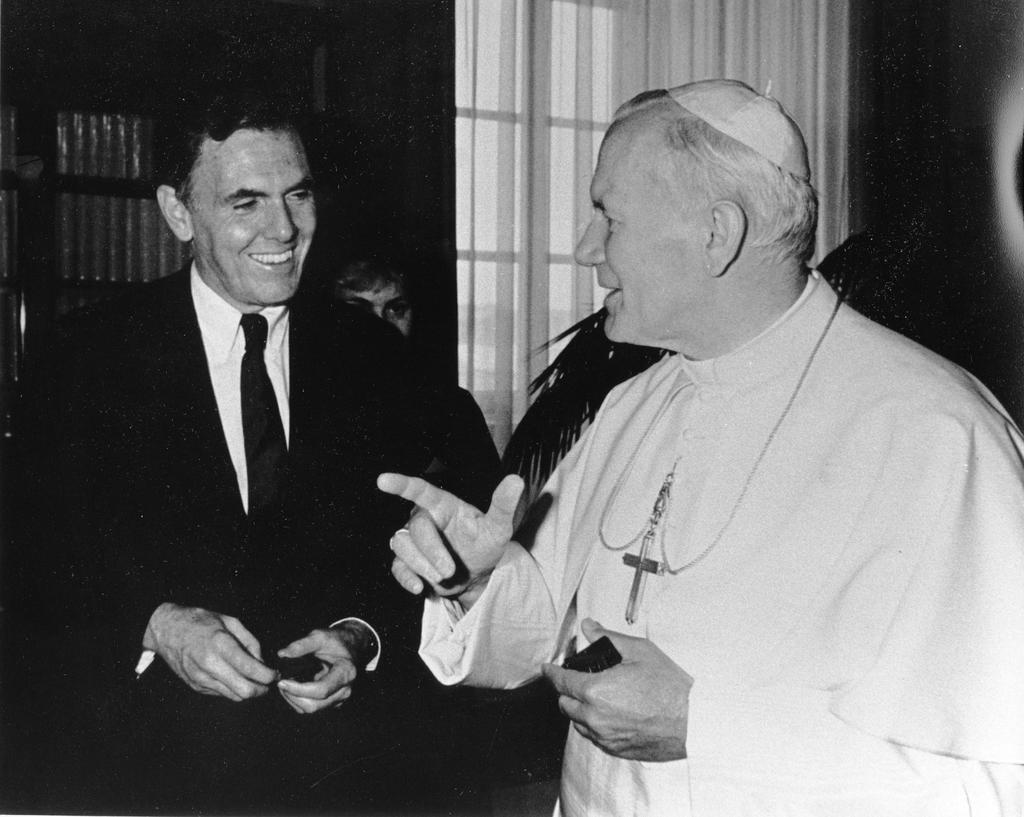Can you describe this image briefly? As we can see in the image there are two persons talking. The man on the left is wearing black color jacket and laughing. The man on the right side is wearing white color dress and behind these two persons there is a window. 